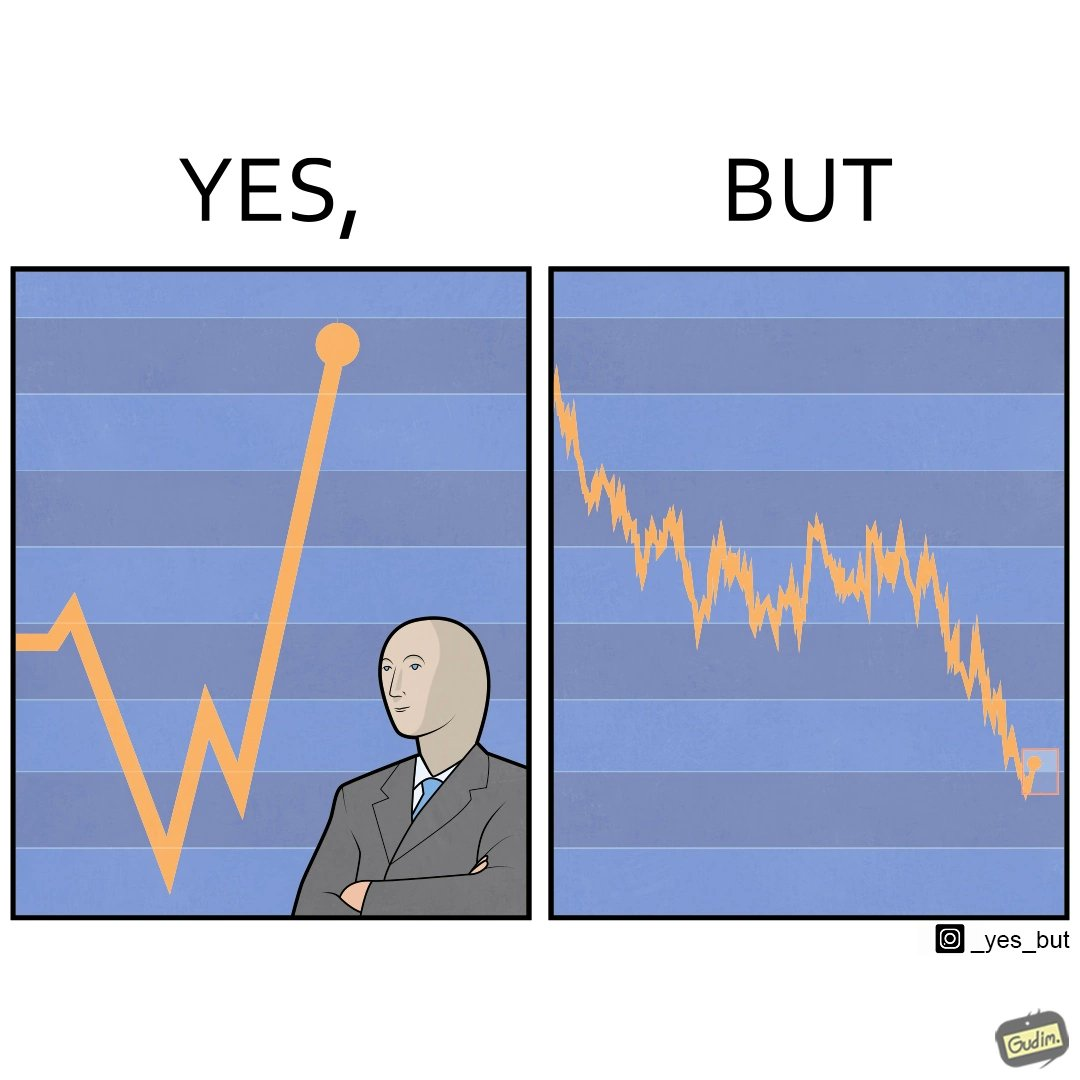What do you see in each half of this image? In the left part of the image: a person feeling proud after looking at the profit in his stocks investment In the right part of the image: a graph representing loss in some stocks 